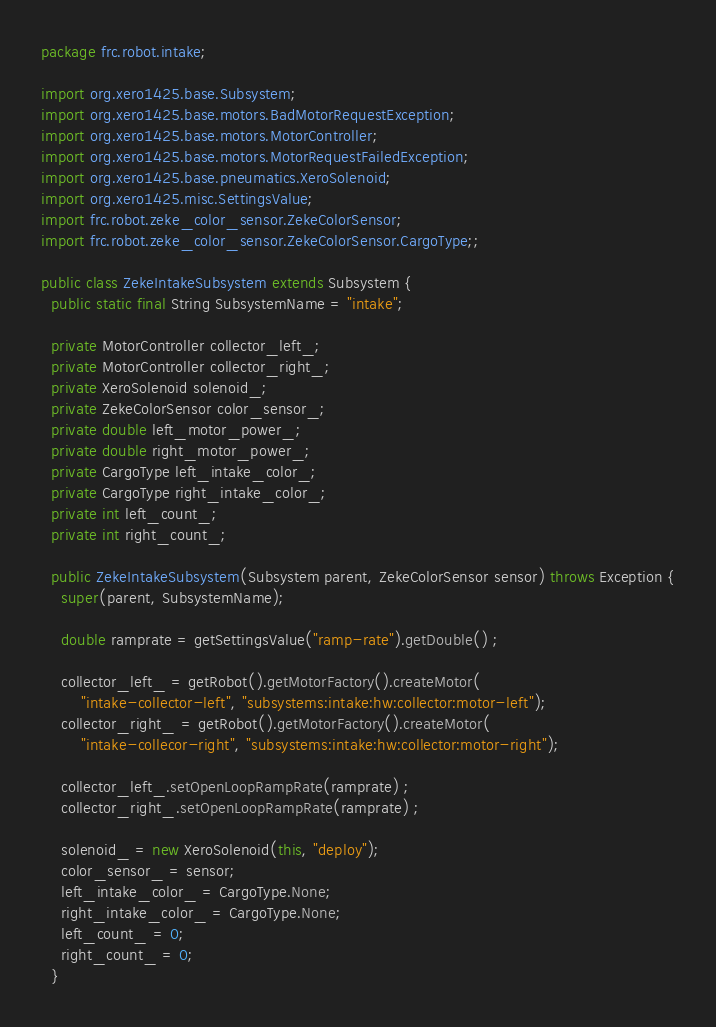Convert code to text. <code><loc_0><loc_0><loc_500><loc_500><_Java_>package frc.robot.intake;

import org.xero1425.base.Subsystem;
import org.xero1425.base.motors.BadMotorRequestException;
import org.xero1425.base.motors.MotorController;
import org.xero1425.base.motors.MotorRequestFailedException;
import org.xero1425.base.pneumatics.XeroSolenoid;
import org.xero1425.misc.SettingsValue;
import frc.robot.zeke_color_sensor.ZekeColorSensor;
import frc.robot.zeke_color_sensor.ZekeColorSensor.CargoType;;

public class ZekeIntakeSubsystem extends Subsystem {
  public static final String SubsystemName = "intake";

  private MotorController collector_left_;
  private MotorController collector_right_;
  private XeroSolenoid solenoid_;
  private ZekeColorSensor color_sensor_;
  private double left_motor_power_;
  private double right_motor_power_;
  private CargoType left_intake_color_;
  private CargoType right_intake_color_;
  private int left_count_;
  private int right_count_;

  public ZekeIntakeSubsystem(Subsystem parent, ZekeColorSensor sensor) throws Exception {
    super(parent, SubsystemName);

    double ramprate = getSettingsValue("ramp-rate").getDouble() ;

    collector_left_ = getRobot().getMotorFactory().createMotor(
        "intake-collector-left", "subsystems:intake:hw:collector:motor-left");
    collector_right_ = getRobot().getMotorFactory().createMotor(
        "intake-collecor-right", "subsystems:intake:hw:collector:motor-right");

    collector_left_.setOpenLoopRampRate(ramprate) ;
    collector_right_.setOpenLoopRampRate(ramprate) ;

    solenoid_ = new XeroSolenoid(this, "deploy");
    color_sensor_ = sensor;
    left_intake_color_ = CargoType.None;
    right_intake_color_ = CargoType.None;
    left_count_ = 0;
    right_count_ = 0;
  }
</code> 